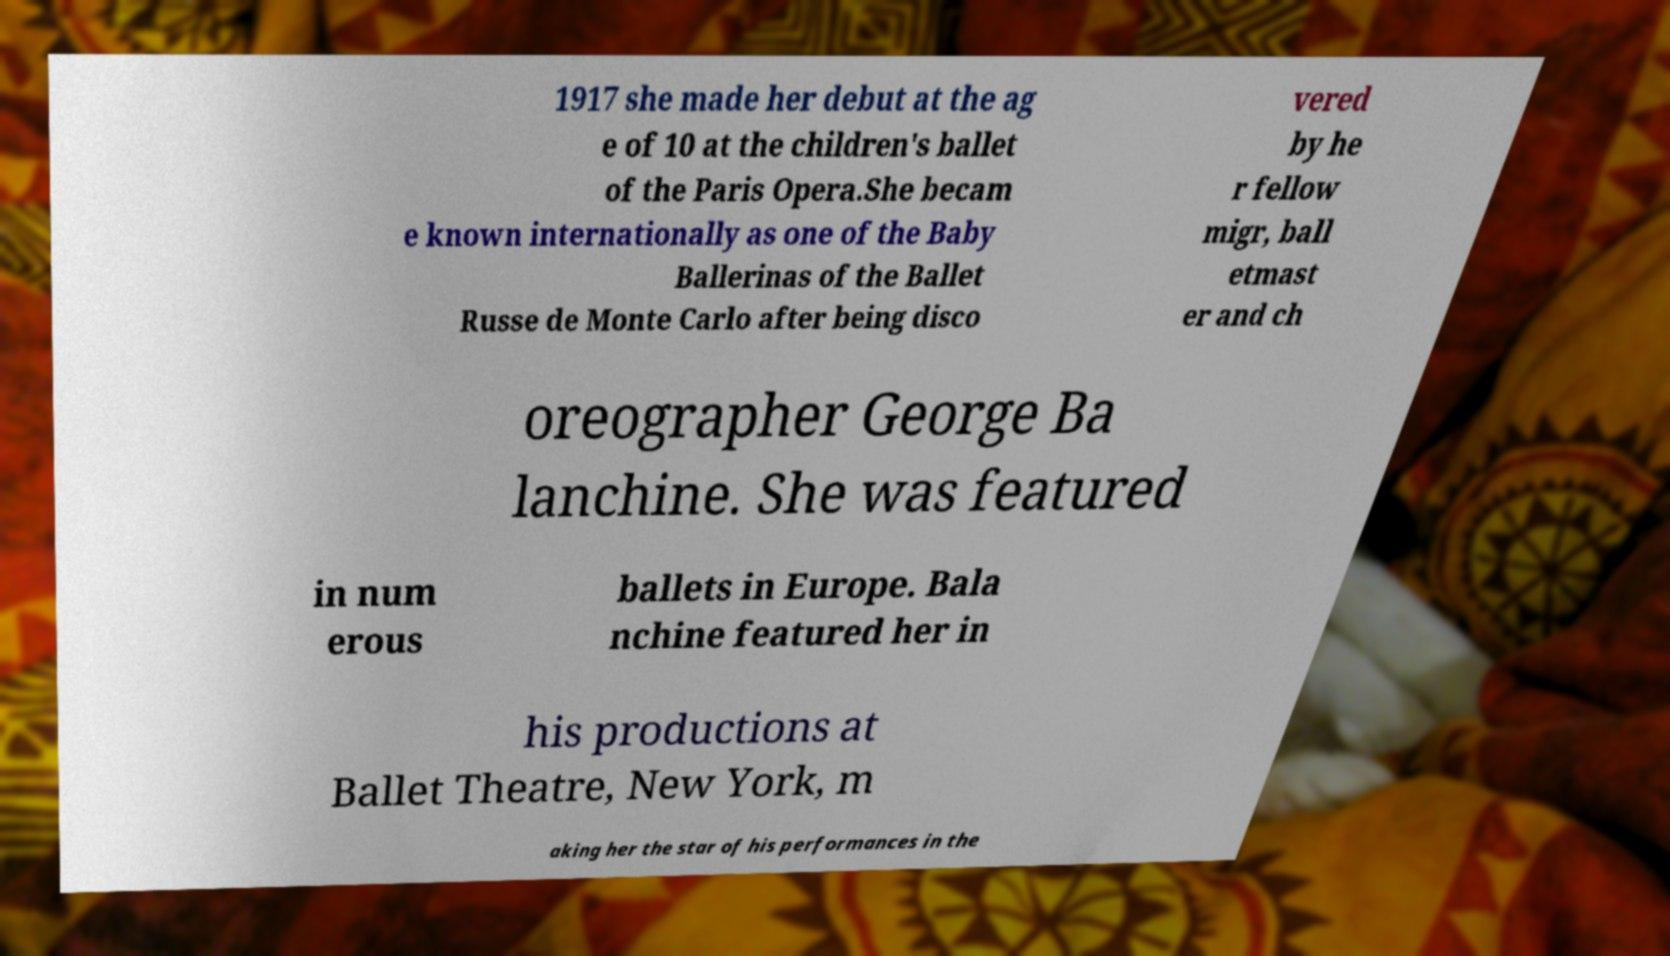Can you read and provide the text displayed in the image?This photo seems to have some interesting text. Can you extract and type it out for me? 1917 she made her debut at the ag e of 10 at the children's ballet of the Paris Opera.She becam e known internationally as one of the Baby Ballerinas of the Ballet Russe de Monte Carlo after being disco vered by he r fellow migr, ball etmast er and ch oreographer George Ba lanchine. She was featured in num erous ballets in Europe. Bala nchine featured her in his productions at Ballet Theatre, New York, m aking her the star of his performances in the 